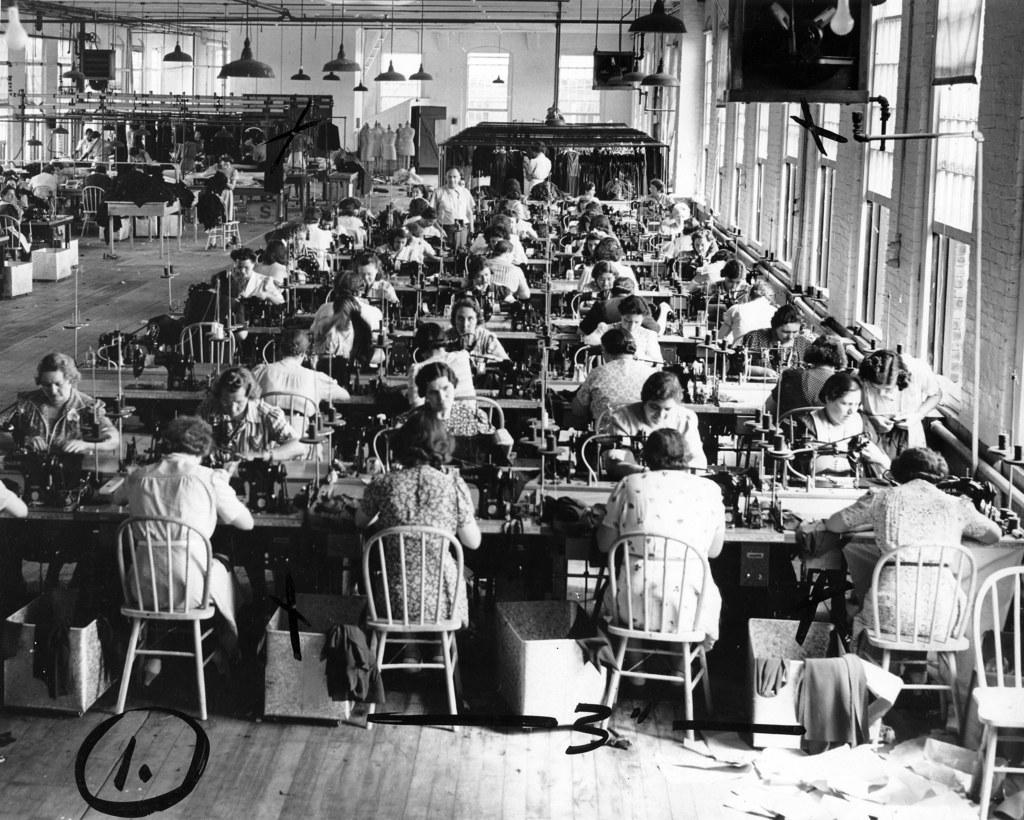What is happening in the image? There is a group of people in the people in the image, and they are working on a sewing machine. Can you describe the activity being performed by the group of people? The group of people are working on a sewing machine, which suggests they might be involved in sewing or garment production. What type of twig is being used by the group of people in the image? There is no twig present in the image; the group of people are working on a sewing machine. Who is the creator of the sewing machine in the image? The creator of the sewing machine is not visible or identifiable in the image. 